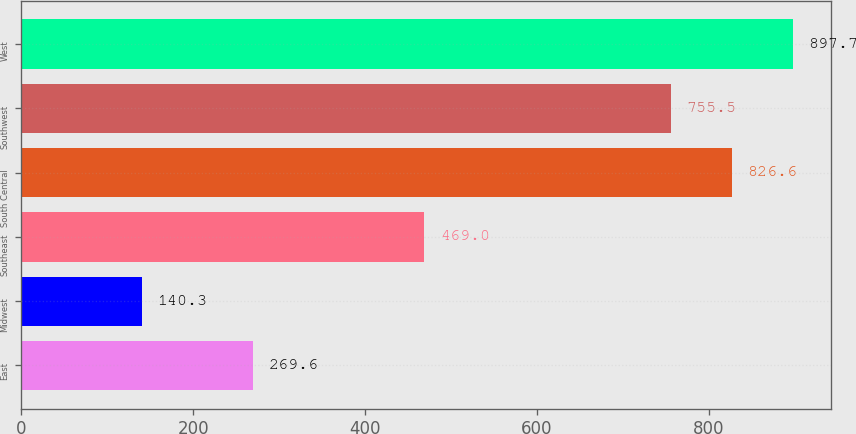Convert chart to OTSL. <chart><loc_0><loc_0><loc_500><loc_500><bar_chart><fcel>East<fcel>Midwest<fcel>Southeast<fcel>South Central<fcel>Southwest<fcel>West<nl><fcel>269.6<fcel>140.3<fcel>469<fcel>826.6<fcel>755.5<fcel>897.7<nl></chart> 